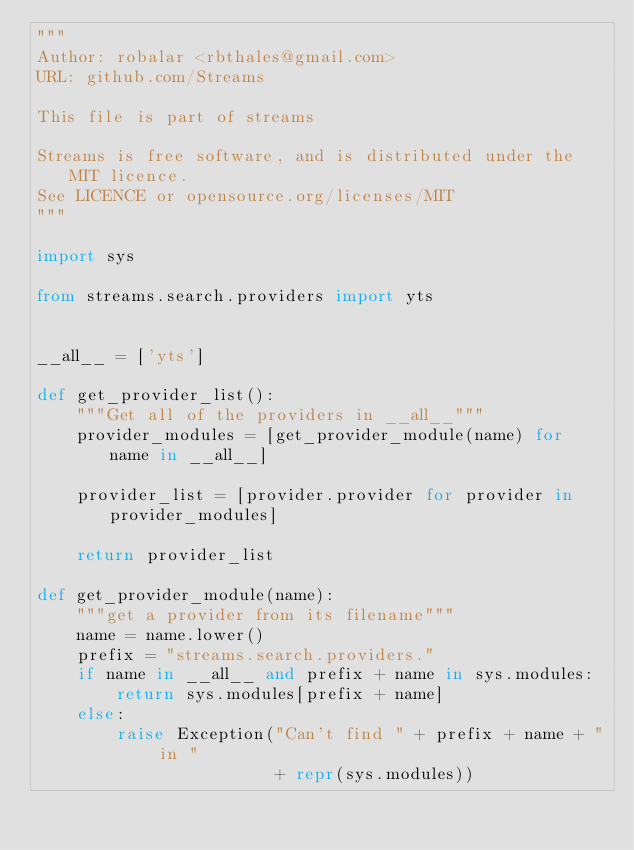<code> <loc_0><loc_0><loc_500><loc_500><_Python_>"""
Author: robalar <rbthales@gmail.com>
URL: github.com/Streams

This file is part of streams

Streams is free software, and is distributed under the MIT licence.
See LICENCE or opensource.org/licenses/MIT
"""

import sys

from streams.search.providers import yts


__all__ = ['yts']

def get_provider_list():
    """Get all of the providers in __all__"""
    provider_modules = [get_provider_module(name) for name in __all__]

    provider_list = [provider.provider for provider in provider_modules]

    return provider_list

def get_provider_module(name):
    """get a provider from its filename"""
    name = name.lower()
    prefix = "streams.search.providers."
    if name in __all__ and prefix + name in sys.modules:
        return sys.modules[prefix + name]
    else:
        raise Exception("Can't find " + prefix + name + " in "
                        + repr(sys.modules))
</code> 